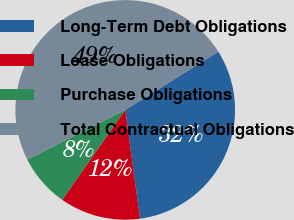Convert chart to OTSL. <chart><loc_0><loc_0><loc_500><loc_500><pie_chart><fcel>Long-Term Debt Obligations<fcel>Lease Obligations<fcel>Purchase Obligations<fcel>Total Contractual Obligations<nl><fcel>31.73%<fcel>11.88%<fcel>7.8%<fcel>48.58%<nl></chart> 